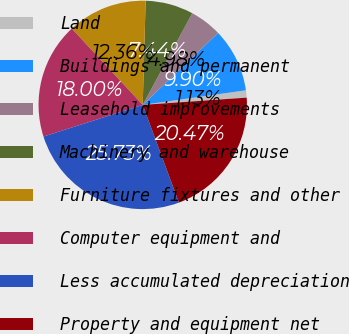Convert chart to OTSL. <chart><loc_0><loc_0><loc_500><loc_500><pie_chart><fcel>Land<fcel>Buildings and permanent<fcel>Leasehold improvements<fcel>Machinery and warehouse<fcel>Furniture fixtures and other<fcel>Computer equipment and<fcel>Less accumulated depreciation<fcel>Property and equipment net<nl><fcel>1.13%<fcel>9.9%<fcel>4.98%<fcel>7.44%<fcel>12.36%<fcel>18.0%<fcel>25.73%<fcel>20.47%<nl></chart> 